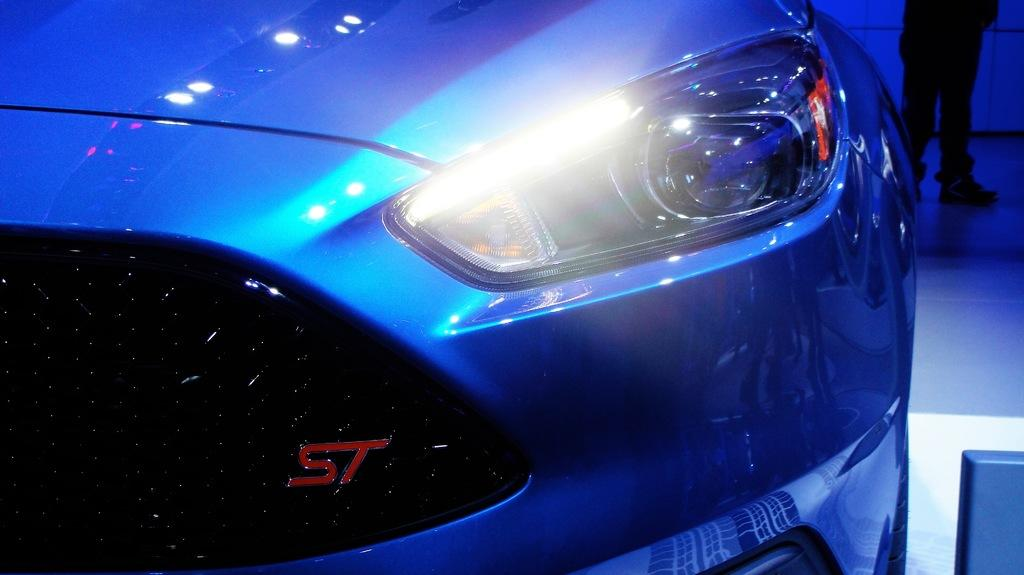What is the main object in the image? There is a vehicle headlight in the image. Can you describe any other elements in the image? The legs of a person are visible in the top right side of the image. Where is the duck nesting in the image? There is no duck or nest present in the image. What type of veil is covering the vehicle headlight in the image? There is no veil covering the vehicle headlight in the image; it is visible and not obstructed. 